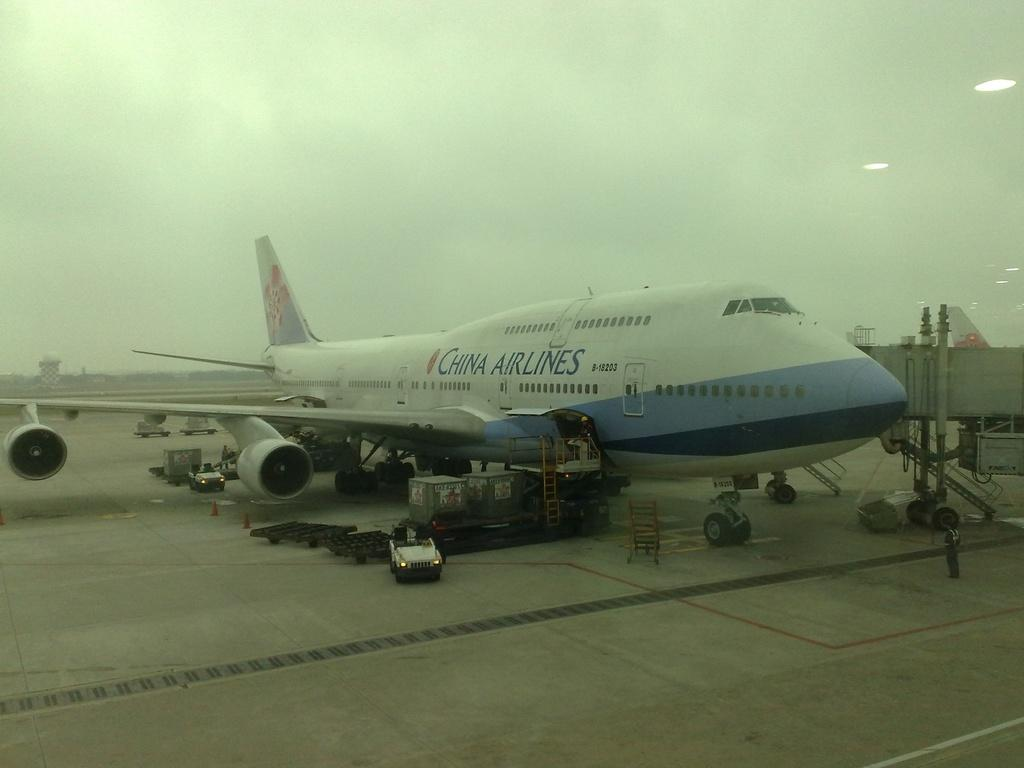<image>
Write a terse but informative summary of the picture. a big CHINA AIRLINES passenger plane on the ground in an airport. 